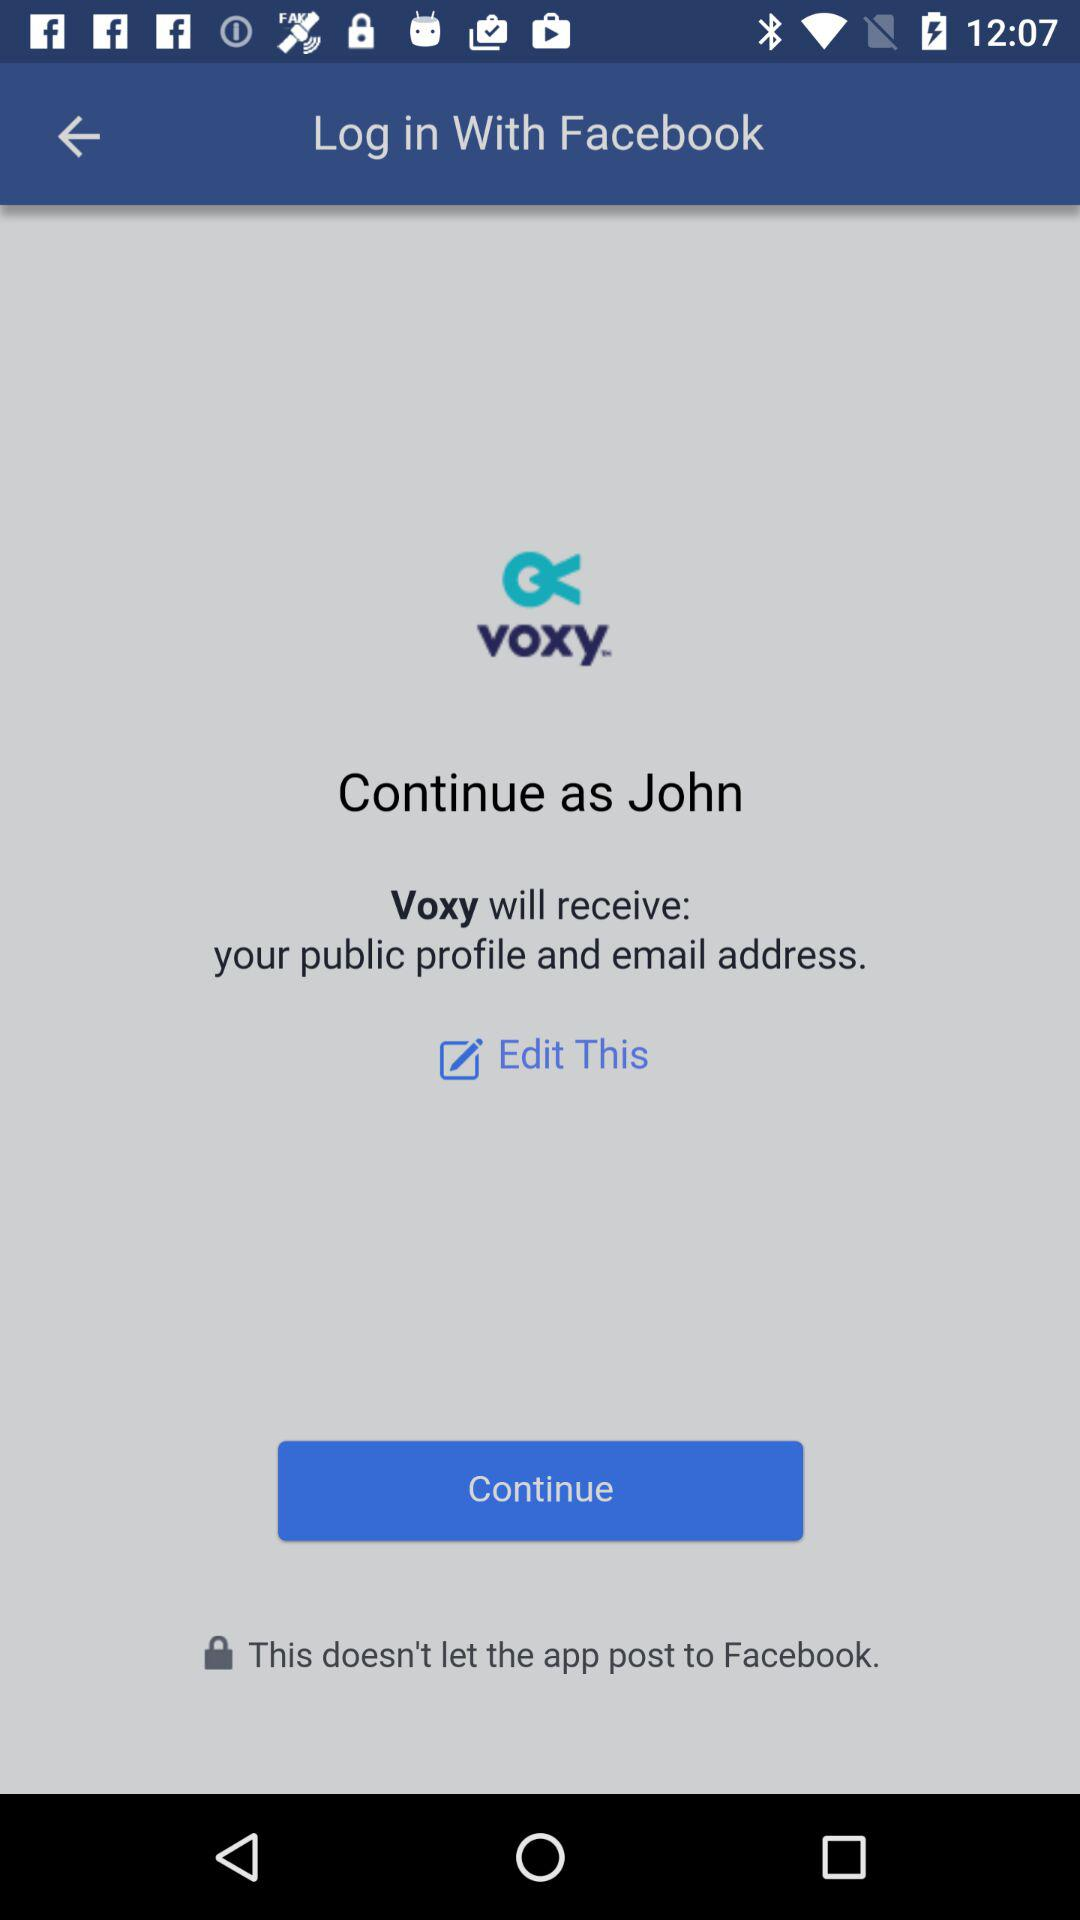What account am I using for login? You're using your Facebook account to log in. 